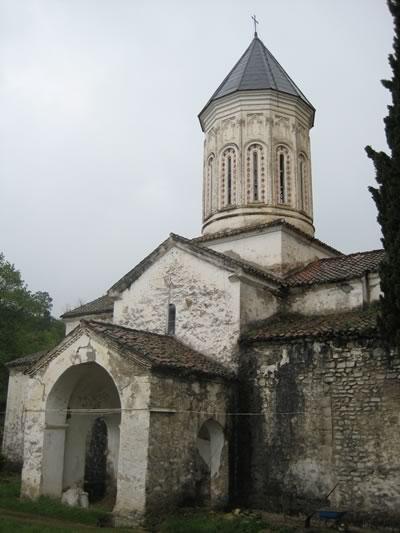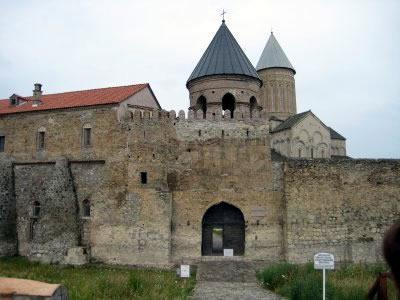The first image is the image on the left, the second image is the image on the right. For the images displayed, is the sentence "At least one image shows a sprawling building that includes a dark blue-gray cone roof on a cylindrical tower." factually correct? Answer yes or no. Yes. The first image is the image on the left, the second image is the image on the right. Analyze the images presented: Is the assertion "There are four visible walkways in front of four traditional buildings." valid? Answer yes or no. No. 